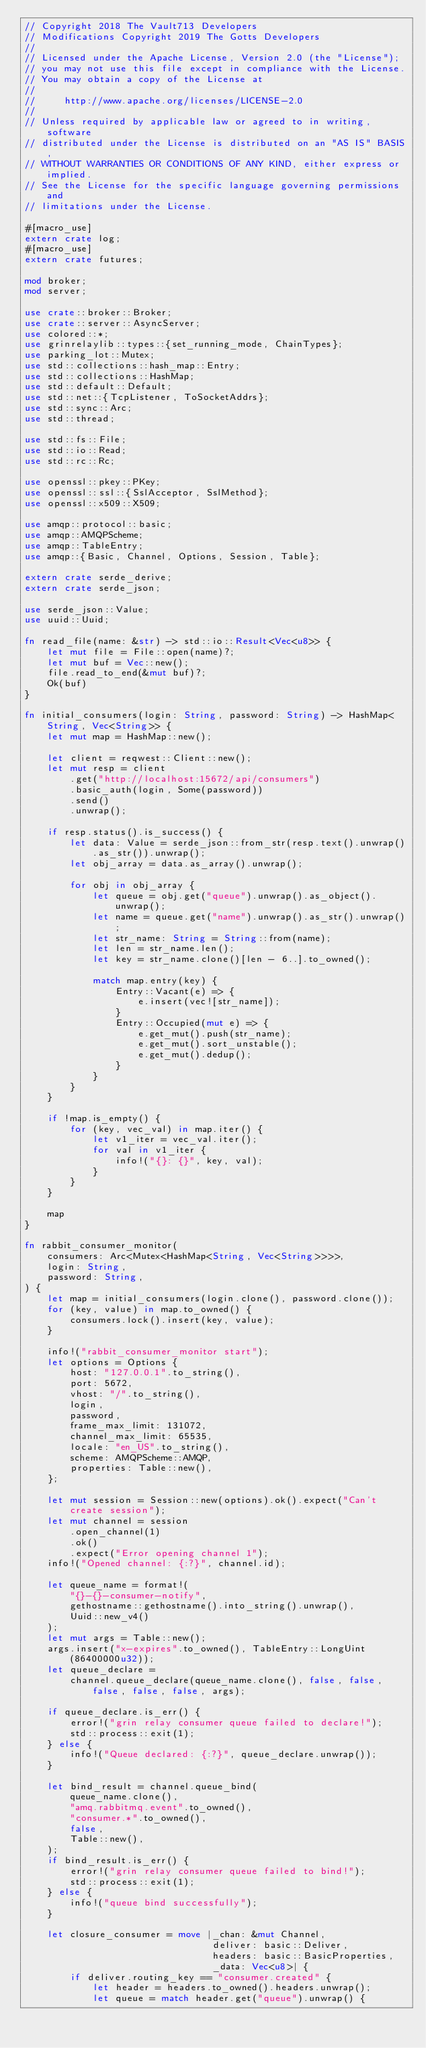Convert code to text. <code><loc_0><loc_0><loc_500><loc_500><_Rust_>// Copyright 2018 The Vault713 Developers
// Modifications Copyright 2019 The Gotts Developers
//
// Licensed under the Apache License, Version 2.0 (the "License");
// you may not use this file except in compliance with the License.
// You may obtain a copy of the License at
//
//     http://www.apache.org/licenses/LICENSE-2.0
//
// Unless required by applicable law or agreed to in writing, software
// distributed under the License is distributed on an "AS IS" BASIS,
// WITHOUT WARRANTIES OR CONDITIONS OF ANY KIND, either express or implied.
// See the License for the specific language governing permissions and
// limitations under the License.

#[macro_use]
extern crate log;
#[macro_use]
extern crate futures;

mod broker;
mod server;

use crate::broker::Broker;
use crate::server::AsyncServer;
use colored::*;
use grinrelaylib::types::{set_running_mode, ChainTypes};
use parking_lot::Mutex;
use std::collections::hash_map::Entry;
use std::collections::HashMap;
use std::default::Default;
use std::net::{TcpListener, ToSocketAddrs};
use std::sync::Arc;
use std::thread;

use std::fs::File;
use std::io::Read;
use std::rc::Rc;

use openssl::pkey::PKey;
use openssl::ssl::{SslAcceptor, SslMethod};
use openssl::x509::X509;

use amqp::protocol::basic;
use amqp::AMQPScheme;
use amqp::TableEntry;
use amqp::{Basic, Channel, Options, Session, Table};

extern crate serde_derive;
extern crate serde_json;

use serde_json::Value;
use uuid::Uuid;

fn read_file(name: &str) -> std::io::Result<Vec<u8>> {
	let mut file = File::open(name)?;
	let mut buf = Vec::new();
	file.read_to_end(&mut buf)?;
	Ok(buf)
}

fn initial_consumers(login: String, password: String) -> HashMap<String, Vec<String>> {
	let mut map = HashMap::new();

	let client = reqwest::Client::new();
	let mut resp = client
		.get("http://localhost:15672/api/consumers")
		.basic_auth(login, Some(password))
		.send()
		.unwrap();

	if resp.status().is_success() {
		let data: Value = serde_json::from_str(resp.text().unwrap().as_str()).unwrap();
		let obj_array = data.as_array().unwrap();

		for obj in obj_array {
			let queue = obj.get("queue").unwrap().as_object().unwrap();
			let name = queue.get("name").unwrap().as_str().unwrap();
			let str_name: String = String::from(name);
			let len = str_name.len();
			let key = str_name.clone()[len - 6..].to_owned();

			match map.entry(key) {
				Entry::Vacant(e) => {
					e.insert(vec![str_name]);
				}
				Entry::Occupied(mut e) => {
					e.get_mut().push(str_name);
					e.get_mut().sort_unstable();
					e.get_mut().dedup();
				}
			}
		}
	}

	if !map.is_empty() {
		for (key, vec_val) in map.iter() {
			let v1_iter = vec_val.iter();
			for val in v1_iter {
				info!("{}: {}", key, val);
			}
		}
	}

	map
}

fn rabbit_consumer_monitor(
	consumers: Arc<Mutex<HashMap<String, Vec<String>>>>,
	login: String,
	password: String,
) {
	let map = initial_consumers(login.clone(), password.clone());
	for (key, value) in map.to_owned() {
		consumers.lock().insert(key, value);
	}

	info!("rabbit_consumer_monitor start");
	let options = Options {
		host: "127.0.0.1".to_string(),
		port: 5672,
		vhost: "/".to_string(),
		login,
		password,
		frame_max_limit: 131072,
		channel_max_limit: 65535,
		locale: "en_US".to_string(),
		scheme: AMQPScheme::AMQP,
		properties: Table::new(),
	};

	let mut session = Session::new(options).ok().expect("Can't create session");
	let mut channel = session
		.open_channel(1)
		.ok()
		.expect("Error opening channel 1");
	info!("Opened channel: {:?}", channel.id);

	let queue_name = format!(
		"{}-{}-consumer-notify",
		gethostname::gethostname().into_string().unwrap(),
		Uuid::new_v4()
	);
	let mut args = Table::new();
	args.insert("x-expires".to_owned(), TableEntry::LongUint(86400000u32));
	let queue_declare =
		channel.queue_declare(queue_name.clone(), false, false, false, false, false, args);

	if queue_declare.is_err() {
		error!("grin relay consumer queue failed to declare!");
		std::process::exit(1);
	} else {
		info!("Queue declared: {:?}", queue_declare.unwrap());
	}

	let bind_result = channel.queue_bind(
		queue_name.clone(),
		"amq.rabbitmq.event".to_owned(),
		"consumer.*".to_owned(),
		false,
		Table::new(),
	);
	if bind_result.is_err() {
		error!("grin relay consumer queue failed to bind!");
		std::process::exit(1);
	} else {
		info!("queue bind successfully");
	}

	let closure_consumer = move |_chan: &mut Channel,
	                             deliver: basic::Deliver,
	                             headers: basic::BasicProperties,
	                             _data: Vec<u8>| {
		if deliver.routing_key == "consumer.created" {
			let header = headers.to_owned().headers.unwrap();
			let queue = match header.get("queue").unwrap() {</code> 